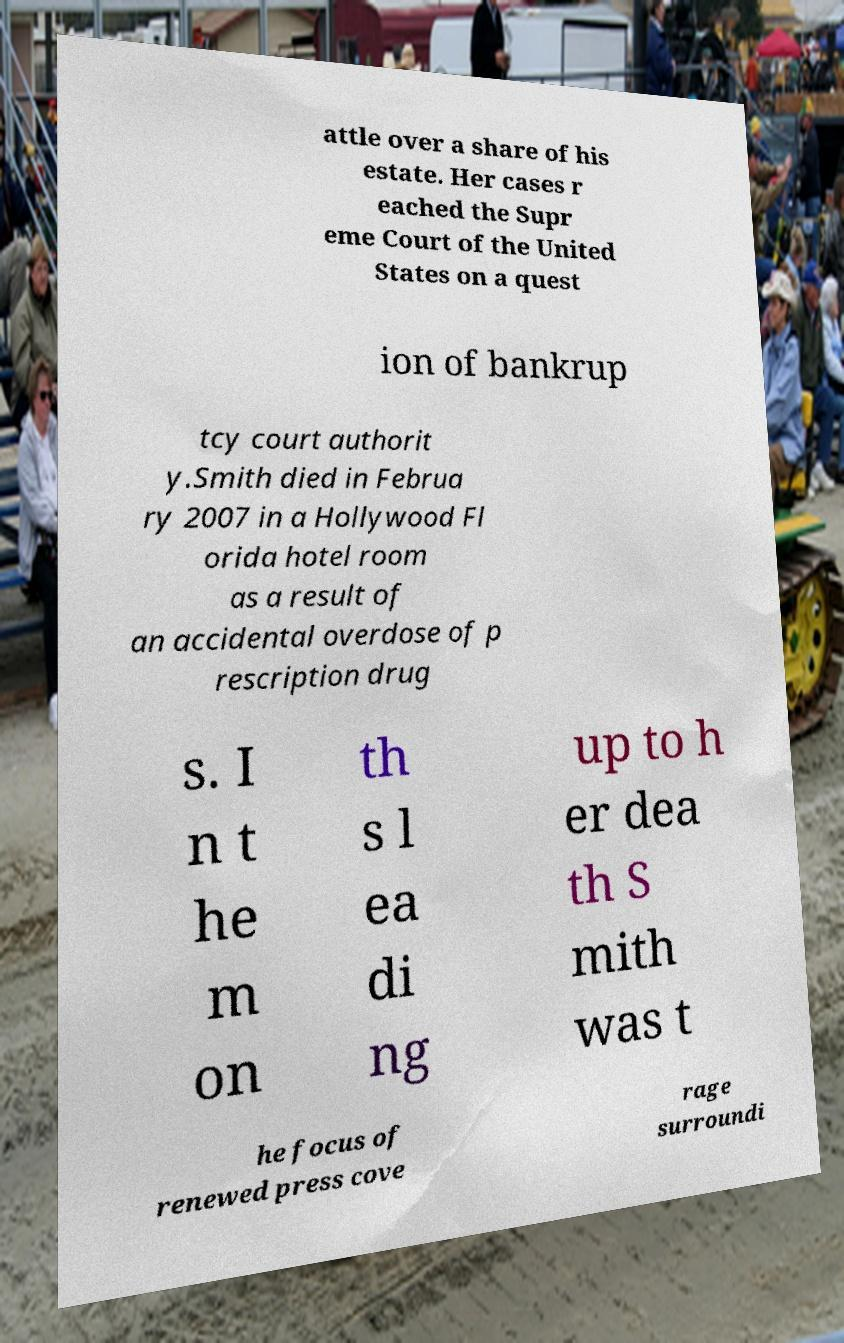Please read and relay the text visible in this image. What does it say? attle over a share of his estate. Her cases r eached the Supr eme Court of the United States on a quest ion of bankrup tcy court authorit y.Smith died in Februa ry 2007 in a Hollywood Fl orida hotel room as a result of an accidental overdose of p rescription drug s. I n t he m on th s l ea di ng up to h er dea th S mith was t he focus of renewed press cove rage surroundi 